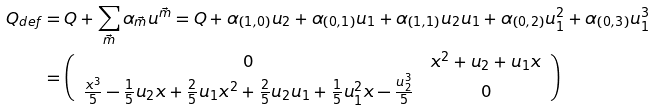<formula> <loc_0><loc_0><loc_500><loc_500>Q _ { d e f } & = Q + \sum _ { \vec { m } } \alpha _ { \vec { m } } u ^ { \vec { m } } = Q + \alpha _ { ( 1 , 0 ) } u _ { 2 } + \alpha _ { ( 0 , 1 ) } u _ { 1 } + \alpha _ { ( 1 , 1 ) } u _ { 2 } u _ { 1 } + \alpha _ { ( 0 , 2 ) } u _ { 1 } ^ { 2 } + \alpha _ { ( 0 , 3 ) } u _ { 1 } ^ { 3 } \\ & = \left ( \begin{array} { c c } 0 & x ^ { 2 } + u _ { 2 } + u _ { 1 } x \\ \frac { x ^ { 3 } } { 5 } - \frac { 1 } { 5 } u _ { 2 } x + \frac { 2 } { 5 } u _ { 1 } x ^ { 2 } + \frac { 2 } { 5 } u _ { 2 } u _ { 1 } + \frac { 1 } { 5 } u _ { 1 } ^ { 2 } x - \frac { u _ { 2 } ^ { 3 } } { 5 } & 0 \end{array} \right )</formula> 